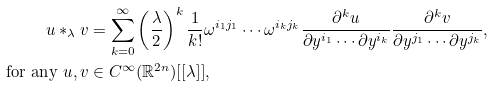Convert formula to latex. <formula><loc_0><loc_0><loc_500><loc_500>u \ast _ { \lambda } v & = \sum _ { k = 0 } ^ { \infty } \left ( \frac { \lambda } { 2 } \right ) ^ { k } \frac { 1 } { k ! } \omega ^ { i _ { 1 } j _ { 1 } } \cdots \omega ^ { i _ { k } j _ { k } } \frac { \partial ^ { k } u } { \partial y ^ { i _ { 1 } } \cdots \partial y ^ { i _ { k } } } \frac { \partial ^ { k } v } { \partial y ^ { j _ { 1 } } \cdots \partial y ^ { j _ { k } } } , \\ \text { for any } u , v & \in C ^ { \infty } ( \mathbb { R } ^ { 2 n } ) [ [ \lambda ] ] ,</formula> 